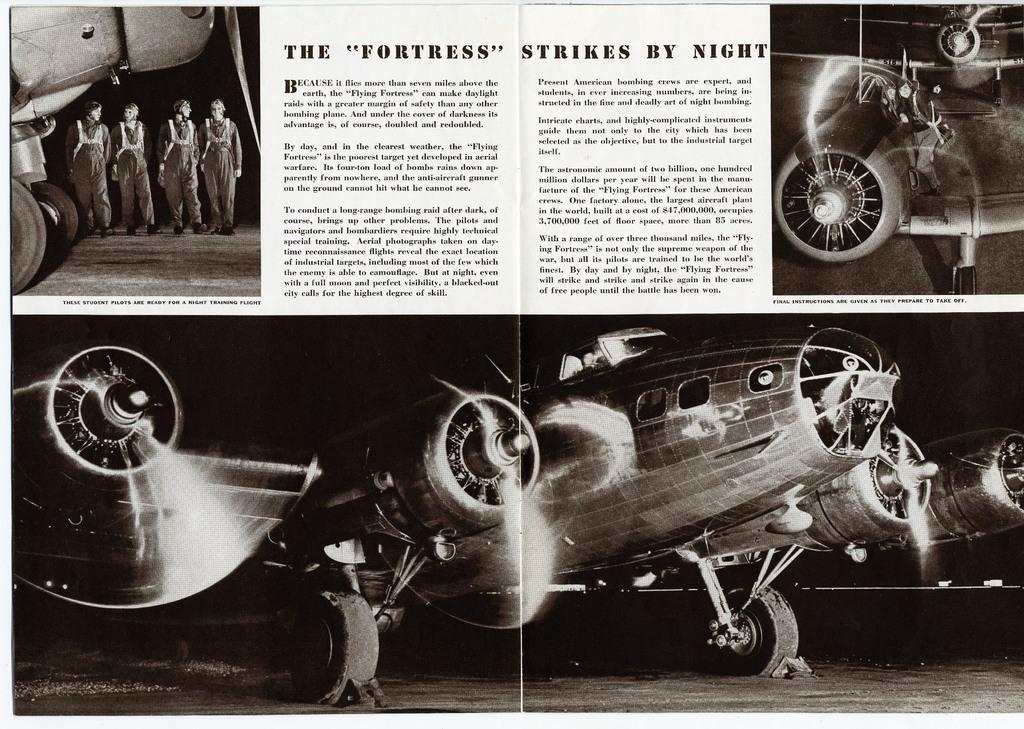How would you summarize this image in a sentence or two? In this image there is a poster with pictures of helicopter and the few people beside it and there is some text written on it. 